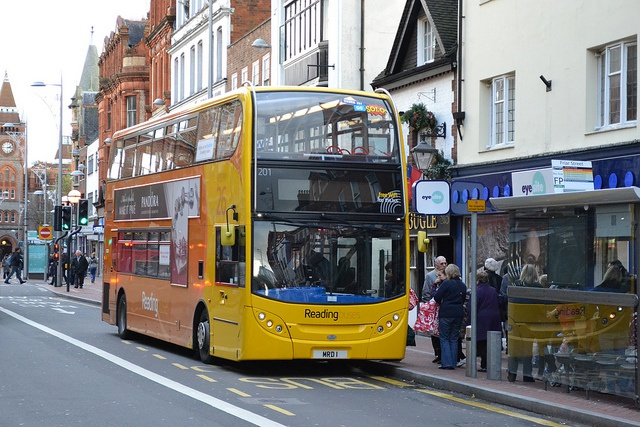Describe the objects in this image and their specific colors. I can see bus in white, black, gray, olive, and darkgray tones, people in white, black, navy, and gray tones, people in white, black, navy, gray, and darkgray tones, handbag in white, brown, darkgray, and gray tones, and people in white, gray, black, darkgray, and navy tones in this image. 